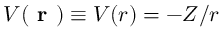Convert formula to latex. <formula><loc_0><loc_0><loc_500><loc_500>V ( r ) \equiv V ( r ) = - Z / r</formula> 